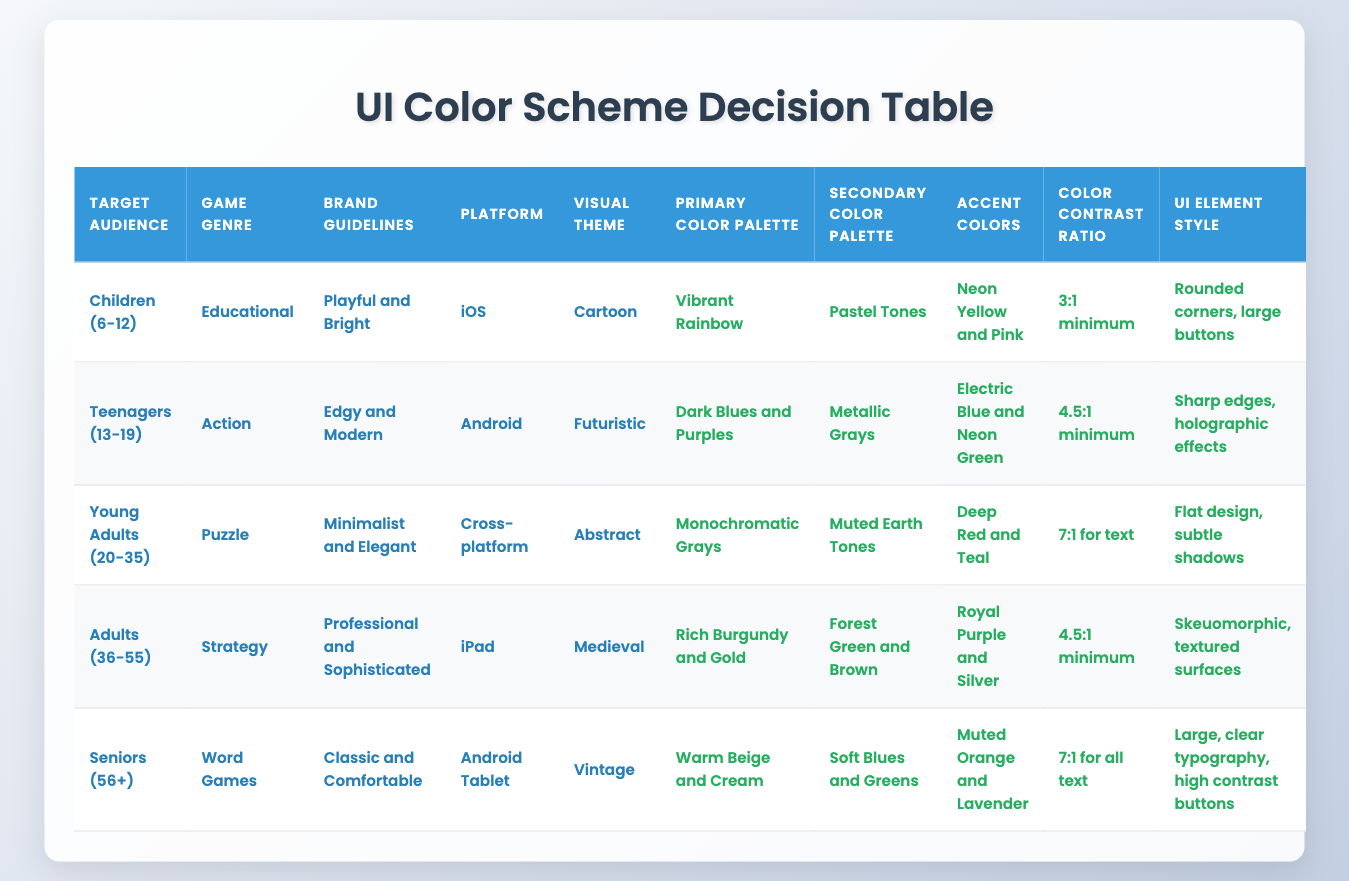What is the primary color palette for games targeting children aged 6-12? The table indicates that for the target audience of children (6-12) in an educational game, the primary color palette is "Vibrant Rainbow."
Answer: Vibrant Rainbow Which visual theme is associated with strategy games for adults aged 36-55? According to the table, the visual theme for strategy games aimed at adults (36-55) is "Medieval."
Answer: Medieval Do both games for seniors and young adults use a color contrast ratio of 7:1? By checking the table, the game for seniors (56+) uses a 7:1 contrast ratio for all text, while the game for young adults (20-35) has a contrast ratio of 7:1 specifically for text. Therefore, the statement is true based on the table data.
Answer: Yes What are the accent colors for the action genre targeted at teenagers? The table specifies that the accent colors for the action genre aimed at teenagers (13-19) are "Electric Blue and Neon Green."
Answer: Electric Blue and Neon Green Which primary color palette has the highest color contrast ratio? Evaluating the highest contrast ratio from the table, "7:1 for text" is found in the puzzle genre for young adults (20-35) and in the word games for seniors (56+). However, it is the young adults' game that corresponds with a monochromatic primary color palette of "Monochromatic Grays." Hence, that is the primary color palette associated with the highest contrast ratio.
Answer: Monochromatic Grays Does the platform "iPad" have a specific UI element style mentioned, and if so, what is it? Indeed, the table shows that the platform "iPad" is linked to the UI element style of "Skeuomorphic, textured surfaces." Therefore, this statement is true and provides the specific style used for that platform.
Answer: Yes, Skeuomorphic, textured surfaces Which brand guidelines apply to educational games for children? According to the table, the brand guidelines for educational games targeting children (6-12) are "Playful and Bright."
Answer: Playful and Bright How many different secondary color palettes are used across all audience groups? From a review of the table, there are five unique secondary color palettes listed: "Pastel Tones," "Metallic Grays," "Muted Earth Tones," "Forest Green and Brown," and "Soft Blues and Greens." Adding these distinct palettes gives a total of five.
Answer: 5 